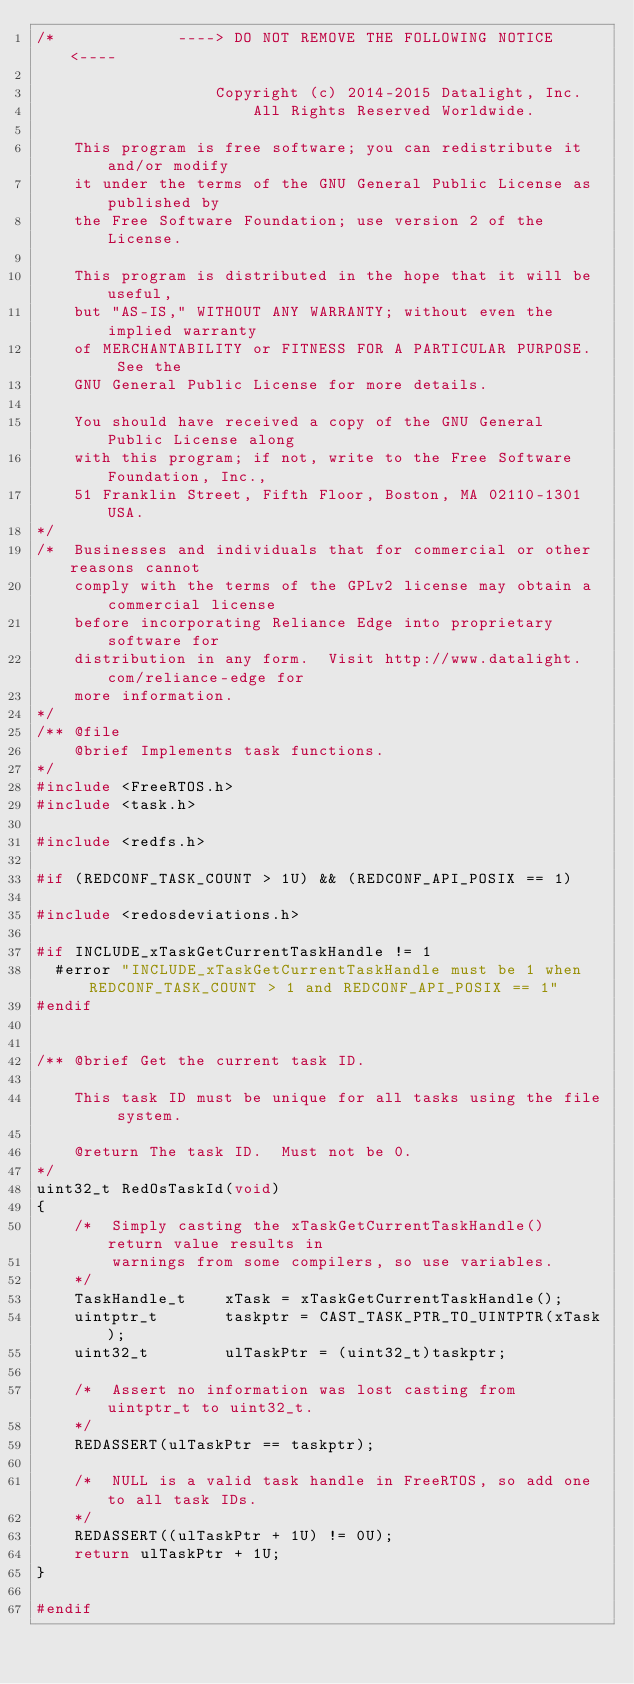Convert code to text. <code><loc_0><loc_0><loc_500><loc_500><_C_>/*             ----> DO NOT REMOVE THE FOLLOWING NOTICE <----

                   Copyright (c) 2014-2015 Datalight, Inc.
                       All Rights Reserved Worldwide.

    This program is free software; you can redistribute it and/or modify
    it under the terms of the GNU General Public License as published by
    the Free Software Foundation; use version 2 of the License.

    This program is distributed in the hope that it will be useful,
    but "AS-IS," WITHOUT ANY WARRANTY; without even the implied warranty
    of MERCHANTABILITY or FITNESS FOR A PARTICULAR PURPOSE.  See the
    GNU General Public License for more details.

    You should have received a copy of the GNU General Public License along
    with this program; if not, write to the Free Software Foundation, Inc.,
    51 Franklin Street, Fifth Floor, Boston, MA 02110-1301 USA.
*/
/*  Businesses and individuals that for commercial or other reasons cannot
    comply with the terms of the GPLv2 license may obtain a commercial license
    before incorporating Reliance Edge into proprietary software for
    distribution in any form.  Visit http://www.datalight.com/reliance-edge for
    more information.
*/
/** @file
    @brief Implements task functions.
*/
#include <FreeRTOS.h>
#include <task.h>

#include <redfs.h>

#if (REDCONF_TASK_COUNT > 1U) && (REDCONF_API_POSIX == 1)

#include <redosdeviations.h>

#if INCLUDE_xTaskGetCurrentTaskHandle != 1
  #error "INCLUDE_xTaskGetCurrentTaskHandle must be 1 when REDCONF_TASK_COUNT > 1 and REDCONF_API_POSIX == 1"
#endif


/** @brief Get the current task ID.

    This task ID must be unique for all tasks using the file system.

    @return The task ID.  Must not be 0.
*/
uint32_t RedOsTaskId(void)
{
    /*  Simply casting the xTaskGetCurrentTaskHandle() return value results in
        warnings from some compilers, so use variables.
    */
    TaskHandle_t    xTask = xTaskGetCurrentTaskHandle();
    uintptr_t       taskptr = CAST_TASK_PTR_TO_UINTPTR(xTask);
    uint32_t        ulTaskPtr = (uint32_t)taskptr;

    /*  Assert no information was lost casting from uintptr_t to uint32_t.
    */
    REDASSERT(ulTaskPtr == taskptr);

    /*  NULL is a valid task handle in FreeRTOS, so add one to all task IDs.
    */
    REDASSERT((ulTaskPtr + 1U) != 0U);
    return ulTaskPtr + 1U;
}

#endif

</code> 